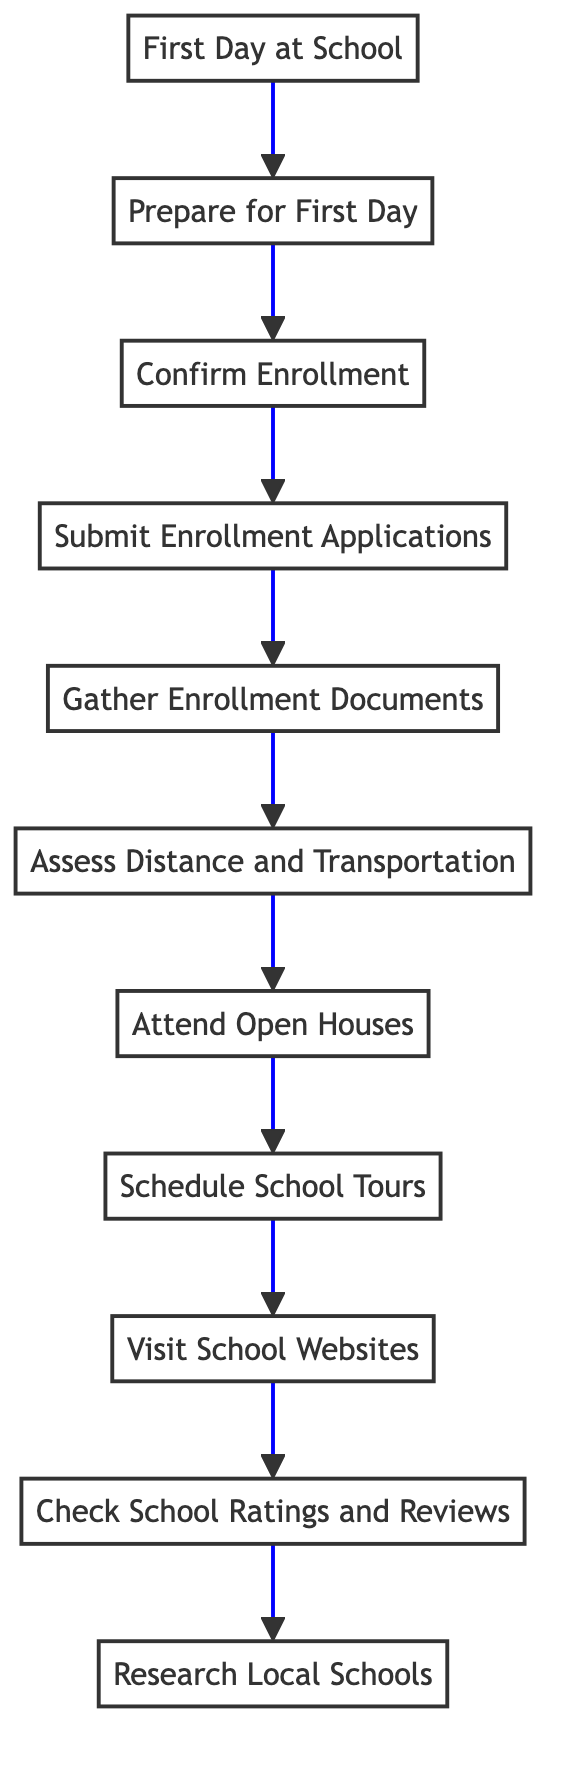What is the first step in the enrollment process? The first step in the diagram is labeled "Research Local Schools," indicating that this is where the process starts.
Answer: Research Local Schools How many steps are there in total? By counting each individual step represented in the flow chart, we find there are 11 distinct steps listed.
Answer: 11 What step comes after "Gather Enrollment Documents"? The diagram shows that "Submit Enrollment Applications" follows after "Gather Enrollment Documents," as indicated by the arrow pointing upwards.
Answer: Submit Enrollment Applications What is the last step in the process? The diagram clearly states that the last step at the top is "First Day at School," which marks the conclusion of the enrollment process.
Answer: First Day at School Which step involves visiting schools in person? The step labeled "Schedule School Tours" directly refers to arranging visits to see the schools in person, as indicated in the diagram.
Answer: Schedule School Tours Which two steps focus on researching and assessing schools? "Research Local Schools" and "Check School Ratings and Reviews" are the two steps focused on initial research and evaluation of schools, connected by an upward arrow.
Answer: Research Local Schools, Check School Ratings and Reviews What documents are needed before submitting the enrollment applications? "Gather Enrollment Documents" specifies collecting necessary documents like birth certificates and immunization records, which come directly before submitting enrollment applications.
Answer: Birth certificates, immunization records, previous school transcripts What is the purpose of attending open houses? The diagram states that attending open houses helps to get a sense of the community and allows for asking questions in person, indicating community engagement and information gathering.
Answer: Community engagement and information gathering Which step emphasizes the importance of speaking with your child? The step "Prepare for First Day" highlights the importance of talking to your child about their new school as part of the preparations for their first day.
Answer: Prepare for First Day 